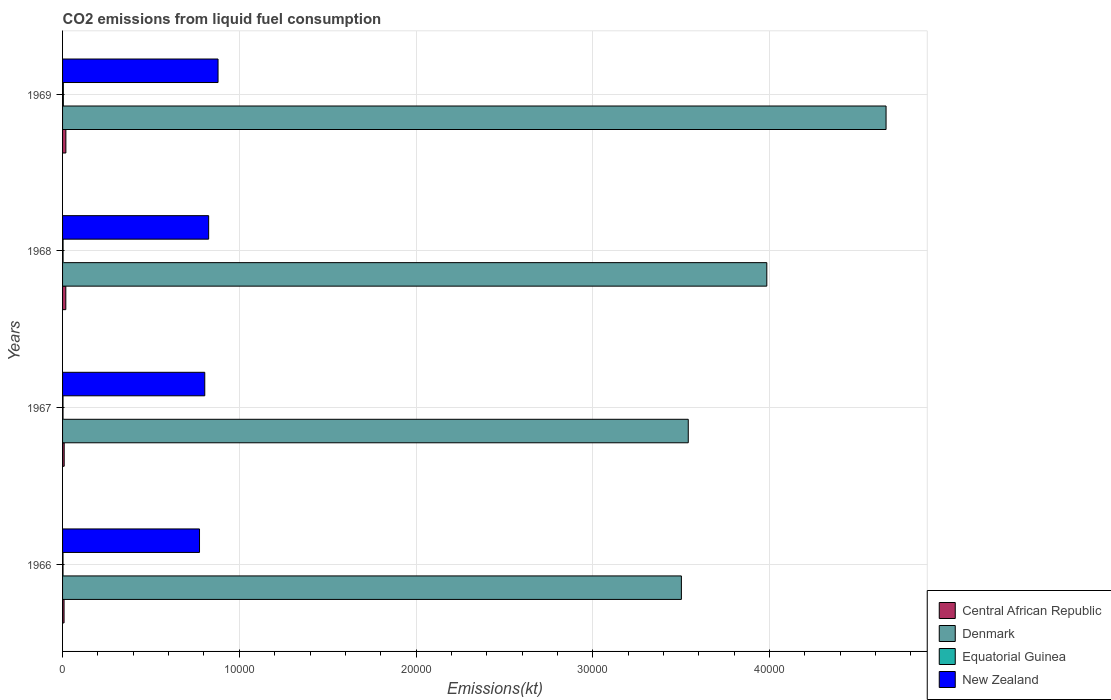How many groups of bars are there?
Ensure brevity in your answer.  4. How many bars are there on the 2nd tick from the bottom?
Offer a very short reply. 4. What is the label of the 3rd group of bars from the top?
Provide a succinct answer. 1967. In how many cases, is the number of bars for a given year not equal to the number of legend labels?
Offer a very short reply. 0. What is the amount of CO2 emitted in New Zealand in 1968?
Your answer should be compact. 8265.42. Across all years, what is the maximum amount of CO2 emitted in Denmark?
Offer a very short reply. 4.66e+04. Across all years, what is the minimum amount of CO2 emitted in Denmark?
Your answer should be very brief. 3.50e+04. In which year was the amount of CO2 emitted in Central African Republic maximum?
Give a very brief answer. 1969. In which year was the amount of CO2 emitted in Central African Republic minimum?
Make the answer very short. 1966. What is the total amount of CO2 emitted in Equatorial Guinea in the graph?
Provide a short and direct response. 124.68. What is the difference between the amount of CO2 emitted in Denmark in 1966 and that in 1968?
Ensure brevity in your answer.  -4833.11. What is the difference between the amount of CO2 emitted in Central African Republic in 1969 and the amount of CO2 emitted in New Zealand in 1968?
Keep it short and to the point. -8078.4. What is the average amount of CO2 emitted in Denmark per year?
Offer a terse response. 3.92e+04. In the year 1966, what is the difference between the amount of CO2 emitted in Denmark and amount of CO2 emitted in Equatorial Guinea?
Offer a very short reply. 3.50e+04. In how many years, is the amount of CO2 emitted in New Zealand greater than 28000 kt?
Provide a succinct answer. 0. What is the ratio of the amount of CO2 emitted in New Zealand in 1966 to that in 1967?
Your response must be concise. 0.96. Is the amount of CO2 emitted in Denmark in 1967 less than that in 1969?
Provide a short and direct response. Yes. What is the difference between the highest and the second highest amount of CO2 emitted in Equatorial Guinea?
Your answer should be very brief. 14.67. What is the difference between the highest and the lowest amount of CO2 emitted in Central African Republic?
Provide a succinct answer. 102.68. What does the 4th bar from the top in 1969 represents?
Keep it short and to the point. Central African Republic. What does the 4th bar from the bottom in 1966 represents?
Ensure brevity in your answer.  New Zealand. How many bars are there?
Offer a very short reply. 16. Are the values on the major ticks of X-axis written in scientific E-notation?
Your answer should be compact. No. Does the graph contain any zero values?
Provide a succinct answer. No. Does the graph contain grids?
Offer a terse response. Yes. Where does the legend appear in the graph?
Your response must be concise. Bottom right. How many legend labels are there?
Offer a terse response. 4. What is the title of the graph?
Make the answer very short. CO2 emissions from liquid fuel consumption. What is the label or title of the X-axis?
Provide a short and direct response. Emissions(kt). What is the Emissions(kt) of Central African Republic in 1966?
Offer a very short reply. 84.34. What is the Emissions(kt) in Denmark in 1966?
Your answer should be compact. 3.50e+04. What is the Emissions(kt) in Equatorial Guinea in 1966?
Provide a short and direct response. 25.67. What is the Emissions(kt) in New Zealand in 1966?
Your response must be concise. 7748.37. What is the Emissions(kt) of Central African Republic in 1967?
Ensure brevity in your answer.  91.67. What is the Emissions(kt) of Denmark in 1967?
Provide a succinct answer. 3.54e+04. What is the Emissions(kt) in Equatorial Guinea in 1967?
Your answer should be very brief. 25.67. What is the Emissions(kt) in New Zealand in 1967?
Make the answer very short. 8045.4. What is the Emissions(kt) of Central African Republic in 1968?
Offer a very short reply. 183.35. What is the Emissions(kt) in Denmark in 1968?
Keep it short and to the point. 3.98e+04. What is the Emissions(kt) of Equatorial Guinea in 1968?
Your answer should be very brief. 29.34. What is the Emissions(kt) in New Zealand in 1968?
Provide a short and direct response. 8265.42. What is the Emissions(kt) of Central African Republic in 1969?
Ensure brevity in your answer.  187.02. What is the Emissions(kt) of Denmark in 1969?
Make the answer very short. 4.66e+04. What is the Emissions(kt) in Equatorial Guinea in 1969?
Make the answer very short. 44. What is the Emissions(kt) in New Zealand in 1969?
Make the answer very short. 8797.13. Across all years, what is the maximum Emissions(kt) of Central African Republic?
Keep it short and to the point. 187.02. Across all years, what is the maximum Emissions(kt) in Denmark?
Offer a terse response. 4.66e+04. Across all years, what is the maximum Emissions(kt) of Equatorial Guinea?
Offer a terse response. 44. Across all years, what is the maximum Emissions(kt) of New Zealand?
Your answer should be compact. 8797.13. Across all years, what is the minimum Emissions(kt) of Central African Republic?
Offer a terse response. 84.34. Across all years, what is the minimum Emissions(kt) of Denmark?
Your answer should be compact. 3.50e+04. Across all years, what is the minimum Emissions(kt) of Equatorial Guinea?
Your response must be concise. 25.67. Across all years, what is the minimum Emissions(kt) of New Zealand?
Your answer should be very brief. 7748.37. What is the total Emissions(kt) in Central African Republic in the graph?
Your answer should be compact. 546.38. What is the total Emissions(kt) of Denmark in the graph?
Provide a short and direct response. 1.57e+05. What is the total Emissions(kt) of Equatorial Guinea in the graph?
Offer a terse response. 124.68. What is the total Emissions(kt) in New Zealand in the graph?
Your response must be concise. 3.29e+04. What is the difference between the Emissions(kt) of Central African Republic in 1966 and that in 1967?
Offer a very short reply. -7.33. What is the difference between the Emissions(kt) in Denmark in 1966 and that in 1967?
Your answer should be compact. -388.7. What is the difference between the Emissions(kt) of New Zealand in 1966 and that in 1967?
Keep it short and to the point. -297.03. What is the difference between the Emissions(kt) in Central African Republic in 1966 and that in 1968?
Your answer should be compact. -99.01. What is the difference between the Emissions(kt) in Denmark in 1966 and that in 1968?
Offer a terse response. -4833.11. What is the difference between the Emissions(kt) of Equatorial Guinea in 1966 and that in 1968?
Your response must be concise. -3.67. What is the difference between the Emissions(kt) in New Zealand in 1966 and that in 1968?
Provide a short and direct response. -517.05. What is the difference between the Emissions(kt) of Central African Republic in 1966 and that in 1969?
Provide a succinct answer. -102.68. What is the difference between the Emissions(kt) of Denmark in 1966 and that in 1969?
Give a very brief answer. -1.16e+04. What is the difference between the Emissions(kt) in Equatorial Guinea in 1966 and that in 1969?
Provide a short and direct response. -18.34. What is the difference between the Emissions(kt) of New Zealand in 1966 and that in 1969?
Provide a succinct answer. -1048.76. What is the difference between the Emissions(kt) in Central African Republic in 1967 and that in 1968?
Make the answer very short. -91.67. What is the difference between the Emissions(kt) in Denmark in 1967 and that in 1968?
Your answer should be compact. -4444.4. What is the difference between the Emissions(kt) of Equatorial Guinea in 1967 and that in 1968?
Make the answer very short. -3.67. What is the difference between the Emissions(kt) in New Zealand in 1967 and that in 1968?
Offer a terse response. -220.02. What is the difference between the Emissions(kt) in Central African Republic in 1967 and that in 1969?
Offer a terse response. -95.34. What is the difference between the Emissions(kt) in Denmark in 1967 and that in 1969?
Offer a terse response. -1.12e+04. What is the difference between the Emissions(kt) in Equatorial Guinea in 1967 and that in 1969?
Give a very brief answer. -18.34. What is the difference between the Emissions(kt) in New Zealand in 1967 and that in 1969?
Make the answer very short. -751.74. What is the difference between the Emissions(kt) of Central African Republic in 1968 and that in 1969?
Give a very brief answer. -3.67. What is the difference between the Emissions(kt) of Denmark in 1968 and that in 1969?
Provide a short and direct response. -6747.28. What is the difference between the Emissions(kt) in Equatorial Guinea in 1968 and that in 1969?
Provide a succinct answer. -14.67. What is the difference between the Emissions(kt) in New Zealand in 1968 and that in 1969?
Make the answer very short. -531.72. What is the difference between the Emissions(kt) of Central African Republic in 1966 and the Emissions(kt) of Denmark in 1967?
Offer a very short reply. -3.53e+04. What is the difference between the Emissions(kt) of Central African Republic in 1966 and the Emissions(kt) of Equatorial Guinea in 1967?
Offer a terse response. 58.67. What is the difference between the Emissions(kt) in Central African Republic in 1966 and the Emissions(kt) in New Zealand in 1967?
Your response must be concise. -7961.06. What is the difference between the Emissions(kt) of Denmark in 1966 and the Emissions(kt) of Equatorial Guinea in 1967?
Keep it short and to the point. 3.50e+04. What is the difference between the Emissions(kt) of Denmark in 1966 and the Emissions(kt) of New Zealand in 1967?
Provide a succinct answer. 2.70e+04. What is the difference between the Emissions(kt) in Equatorial Guinea in 1966 and the Emissions(kt) in New Zealand in 1967?
Give a very brief answer. -8019.73. What is the difference between the Emissions(kt) of Central African Republic in 1966 and the Emissions(kt) of Denmark in 1968?
Provide a short and direct response. -3.98e+04. What is the difference between the Emissions(kt) of Central African Republic in 1966 and the Emissions(kt) of Equatorial Guinea in 1968?
Your answer should be compact. 55.01. What is the difference between the Emissions(kt) of Central African Republic in 1966 and the Emissions(kt) of New Zealand in 1968?
Provide a succinct answer. -8181.08. What is the difference between the Emissions(kt) of Denmark in 1966 and the Emissions(kt) of Equatorial Guinea in 1968?
Ensure brevity in your answer.  3.50e+04. What is the difference between the Emissions(kt) of Denmark in 1966 and the Emissions(kt) of New Zealand in 1968?
Your answer should be very brief. 2.67e+04. What is the difference between the Emissions(kt) of Equatorial Guinea in 1966 and the Emissions(kt) of New Zealand in 1968?
Provide a short and direct response. -8239.75. What is the difference between the Emissions(kt) in Central African Republic in 1966 and the Emissions(kt) in Denmark in 1969?
Make the answer very short. -4.65e+04. What is the difference between the Emissions(kt) in Central African Republic in 1966 and the Emissions(kt) in Equatorial Guinea in 1969?
Your response must be concise. 40.34. What is the difference between the Emissions(kt) in Central African Republic in 1966 and the Emissions(kt) in New Zealand in 1969?
Offer a terse response. -8712.79. What is the difference between the Emissions(kt) in Denmark in 1966 and the Emissions(kt) in Equatorial Guinea in 1969?
Your answer should be compact. 3.50e+04. What is the difference between the Emissions(kt) of Denmark in 1966 and the Emissions(kt) of New Zealand in 1969?
Your answer should be very brief. 2.62e+04. What is the difference between the Emissions(kt) of Equatorial Guinea in 1966 and the Emissions(kt) of New Zealand in 1969?
Keep it short and to the point. -8771.46. What is the difference between the Emissions(kt) of Central African Republic in 1967 and the Emissions(kt) of Denmark in 1968?
Offer a terse response. -3.98e+04. What is the difference between the Emissions(kt) in Central African Republic in 1967 and the Emissions(kt) in Equatorial Guinea in 1968?
Give a very brief answer. 62.34. What is the difference between the Emissions(kt) in Central African Republic in 1967 and the Emissions(kt) in New Zealand in 1968?
Give a very brief answer. -8173.74. What is the difference between the Emissions(kt) in Denmark in 1967 and the Emissions(kt) in Equatorial Guinea in 1968?
Your answer should be very brief. 3.54e+04. What is the difference between the Emissions(kt) in Denmark in 1967 and the Emissions(kt) in New Zealand in 1968?
Your response must be concise. 2.71e+04. What is the difference between the Emissions(kt) in Equatorial Guinea in 1967 and the Emissions(kt) in New Zealand in 1968?
Your answer should be compact. -8239.75. What is the difference between the Emissions(kt) of Central African Republic in 1967 and the Emissions(kt) of Denmark in 1969?
Give a very brief answer. -4.65e+04. What is the difference between the Emissions(kt) of Central African Republic in 1967 and the Emissions(kt) of Equatorial Guinea in 1969?
Your answer should be very brief. 47.67. What is the difference between the Emissions(kt) in Central African Republic in 1967 and the Emissions(kt) in New Zealand in 1969?
Offer a terse response. -8705.46. What is the difference between the Emissions(kt) in Denmark in 1967 and the Emissions(kt) in Equatorial Guinea in 1969?
Your answer should be very brief. 3.54e+04. What is the difference between the Emissions(kt) in Denmark in 1967 and the Emissions(kt) in New Zealand in 1969?
Keep it short and to the point. 2.66e+04. What is the difference between the Emissions(kt) in Equatorial Guinea in 1967 and the Emissions(kt) in New Zealand in 1969?
Offer a terse response. -8771.46. What is the difference between the Emissions(kt) of Central African Republic in 1968 and the Emissions(kt) of Denmark in 1969?
Offer a terse response. -4.64e+04. What is the difference between the Emissions(kt) in Central African Republic in 1968 and the Emissions(kt) in Equatorial Guinea in 1969?
Offer a terse response. 139.35. What is the difference between the Emissions(kt) in Central African Republic in 1968 and the Emissions(kt) in New Zealand in 1969?
Ensure brevity in your answer.  -8613.78. What is the difference between the Emissions(kt) in Denmark in 1968 and the Emissions(kt) in Equatorial Guinea in 1969?
Your answer should be compact. 3.98e+04. What is the difference between the Emissions(kt) in Denmark in 1968 and the Emissions(kt) in New Zealand in 1969?
Your answer should be very brief. 3.10e+04. What is the difference between the Emissions(kt) of Equatorial Guinea in 1968 and the Emissions(kt) of New Zealand in 1969?
Offer a very short reply. -8767.8. What is the average Emissions(kt) of Central African Republic per year?
Keep it short and to the point. 136.6. What is the average Emissions(kt) in Denmark per year?
Offer a very short reply. 3.92e+04. What is the average Emissions(kt) of Equatorial Guinea per year?
Make the answer very short. 31.17. What is the average Emissions(kt) in New Zealand per year?
Your answer should be very brief. 8214.08. In the year 1966, what is the difference between the Emissions(kt) of Central African Republic and Emissions(kt) of Denmark?
Make the answer very short. -3.49e+04. In the year 1966, what is the difference between the Emissions(kt) of Central African Republic and Emissions(kt) of Equatorial Guinea?
Make the answer very short. 58.67. In the year 1966, what is the difference between the Emissions(kt) of Central African Republic and Emissions(kt) of New Zealand?
Give a very brief answer. -7664.03. In the year 1966, what is the difference between the Emissions(kt) in Denmark and Emissions(kt) in Equatorial Guinea?
Provide a short and direct response. 3.50e+04. In the year 1966, what is the difference between the Emissions(kt) in Denmark and Emissions(kt) in New Zealand?
Make the answer very short. 2.73e+04. In the year 1966, what is the difference between the Emissions(kt) of Equatorial Guinea and Emissions(kt) of New Zealand?
Provide a succinct answer. -7722.7. In the year 1967, what is the difference between the Emissions(kt) of Central African Republic and Emissions(kt) of Denmark?
Offer a terse response. -3.53e+04. In the year 1967, what is the difference between the Emissions(kt) of Central African Republic and Emissions(kt) of Equatorial Guinea?
Make the answer very short. 66.01. In the year 1967, what is the difference between the Emissions(kt) in Central African Republic and Emissions(kt) in New Zealand?
Give a very brief answer. -7953.72. In the year 1967, what is the difference between the Emissions(kt) of Denmark and Emissions(kt) of Equatorial Guinea?
Provide a short and direct response. 3.54e+04. In the year 1967, what is the difference between the Emissions(kt) of Denmark and Emissions(kt) of New Zealand?
Give a very brief answer. 2.74e+04. In the year 1967, what is the difference between the Emissions(kt) in Equatorial Guinea and Emissions(kt) in New Zealand?
Provide a short and direct response. -8019.73. In the year 1968, what is the difference between the Emissions(kt) of Central African Republic and Emissions(kt) of Denmark?
Give a very brief answer. -3.97e+04. In the year 1968, what is the difference between the Emissions(kt) of Central African Republic and Emissions(kt) of Equatorial Guinea?
Your answer should be very brief. 154.01. In the year 1968, what is the difference between the Emissions(kt) in Central African Republic and Emissions(kt) in New Zealand?
Provide a short and direct response. -8082.07. In the year 1968, what is the difference between the Emissions(kt) of Denmark and Emissions(kt) of Equatorial Guinea?
Provide a short and direct response. 3.98e+04. In the year 1968, what is the difference between the Emissions(kt) in Denmark and Emissions(kt) in New Zealand?
Offer a very short reply. 3.16e+04. In the year 1968, what is the difference between the Emissions(kt) of Equatorial Guinea and Emissions(kt) of New Zealand?
Your response must be concise. -8236.08. In the year 1969, what is the difference between the Emissions(kt) of Central African Republic and Emissions(kt) of Denmark?
Offer a very short reply. -4.64e+04. In the year 1969, what is the difference between the Emissions(kt) of Central African Republic and Emissions(kt) of Equatorial Guinea?
Provide a short and direct response. 143.01. In the year 1969, what is the difference between the Emissions(kt) of Central African Republic and Emissions(kt) of New Zealand?
Provide a succinct answer. -8610.12. In the year 1969, what is the difference between the Emissions(kt) in Denmark and Emissions(kt) in Equatorial Guinea?
Keep it short and to the point. 4.65e+04. In the year 1969, what is the difference between the Emissions(kt) of Denmark and Emissions(kt) of New Zealand?
Your answer should be very brief. 3.78e+04. In the year 1969, what is the difference between the Emissions(kt) of Equatorial Guinea and Emissions(kt) of New Zealand?
Give a very brief answer. -8753.13. What is the ratio of the Emissions(kt) of Equatorial Guinea in 1966 to that in 1967?
Offer a very short reply. 1. What is the ratio of the Emissions(kt) in New Zealand in 1966 to that in 1967?
Keep it short and to the point. 0.96. What is the ratio of the Emissions(kt) in Central African Republic in 1966 to that in 1968?
Your answer should be very brief. 0.46. What is the ratio of the Emissions(kt) of Denmark in 1966 to that in 1968?
Your response must be concise. 0.88. What is the ratio of the Emissions(kt) of Equatorial Guinea in 1966 to that in 1968?
Ensure brevity in your answer.  0.88. What is the ratio of the Emissions(kt) in New Zealand in 1966 to that in 1968?
Offer a terse response. 0.94. What is the ratio of the Emissions(kt) in Central African Republic in 1966 to that in 1969?
Ensure brevity in your answer.  0.45. What is the ratio of the Emissions(kt) of Denmark in 1966 to that in 1969?
Make the answer very short. 0.75. What is the ratio of the Emissions(kt) of Equatorial Guinea in 1966 to that in 1969?
Your answer should be very brief. 0.58. What is the ratio of the Emissions(kt) of New Zealand in 1966 to that in 1969?
Offer a very short reply. 0.88. What is the ratio of the Emissions(kt) in Central African Republic in 1967 to that in 1968?
Your answer should be very brief. 0.5. What is the ratio of the Emissions(kt) in Denmark in 1967 to that in 1968?
Your answer should be compact. 0.89. What is the ratio of the Emissions(kt) in New Zealand in 1967 to that in 1968?
Give a very brief answer. 0.97. What is the ratio of the Emissions(kt) of Central African Republic in 1967 to that in 1969?
Offer a very short reply. 0.49. What is the ratio of the Emissions(kt) of Denmark in 1967 to that in 1969?
Your answer should be very brief. 0.76. What is the ratio of the Emissions(kt) in Equatorial Guinea in 1967 to that in 1969?
Offer a very short reply. 0.58. What is the ratio of the Emissions(kt) in New Zealand in 1967 to that in 1969?
Ensure brevity in your answer.  0.91. What is the ratio of the Emissions(kt) of Central African Republic in 1968 to that in 1969?
Provide a succinct answer. 0.98. What is the ratio of the Emissions(kt) of Denmark in 1968 to that in 1969?
Provide a short and direct response. 0.86. What is the ratio of the Emissions(kt) in New Zealand in 1968 to that in 1969?
Keep it short and to the point. 0.94. What is the difference between the highest and the second highest Emissions(kt) in Central African Republic?
Your answer should be very brief. 3.67. What is the difference between the highest and the second highest Emissions(kt) of Denmark?
Provide a succinct answer. 6747.28. What is the difference between the highest and the second highest Emissions(kt) in Equatorial Guinea?
Your answer should be compact. 14.67. What is the difference between the highest and the second highest Emissions(kt) in New Zealand?
Provide a succinct answer. 531.72. What is the difference between the highest and the lowest Emissions(kt) of Central African Republic?
Give a very brief answer. 102.68. What is the difference between the highest and the lowest Emissions(kt) in Denmark?
Your answer should be very brief. 1.16e+04. What is the difference between the highest and the lowest Emissions(kt) of Equatorial Guinea?
Your response must be concise. 18.34. What is the difference between the highest and the lowest Emissions(kt) in New Zealand?
Ensure brevity in your answer.  1048.76. 